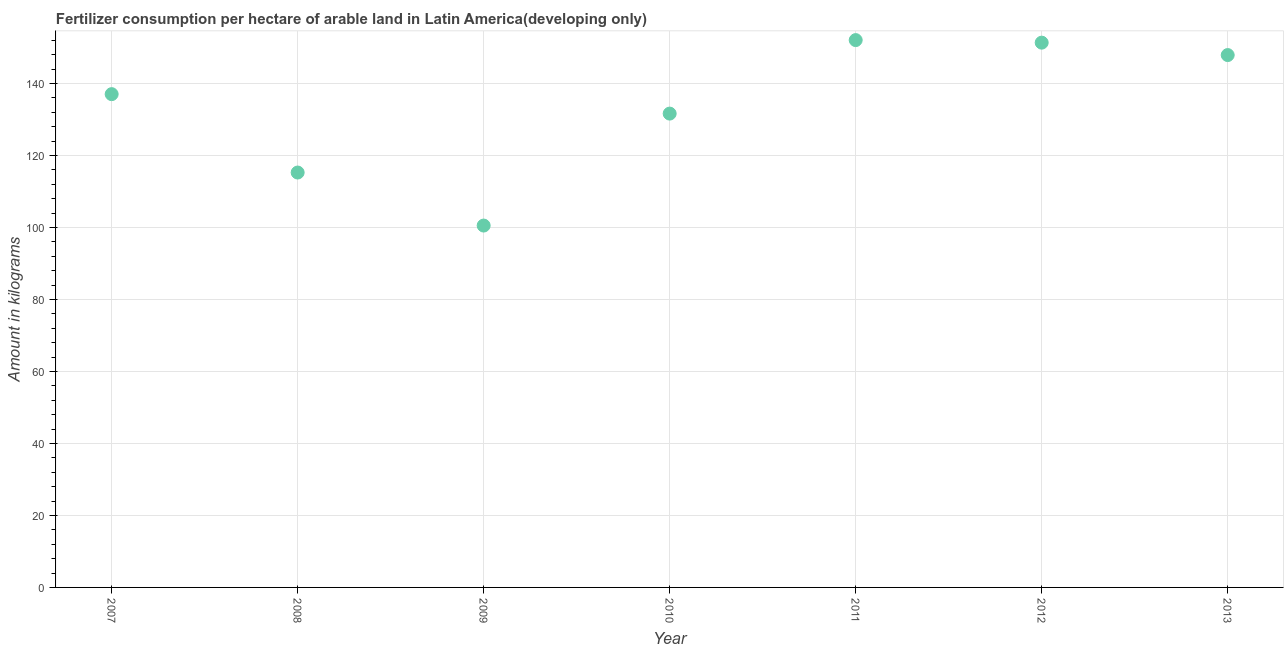What is the amount of fertilizer consumption in 2012?
Make the answer very short. 151.32. Across all years, what is the maximum amount of fertilizer consumption?
Your response must be concise. 152.03. Across all years, what is the minimum amount of fertilizer consumption?
Your answer should be compact. 100.52. In which year was the amount of fertilizer consumption maximum?
Your answer should be compact. 2011. What is the sum of the amount of fertilizer consumption?
Make the answer very short. 935.62. What is the difference between the amount of fertilizer consumption in 2008 and 2009?
Offer a terse response. 14.73. What is the average amount of fertilizer consumption per year?
Ensure brevity in your answer.  133.66. What is the median amount of fertilizer consumption?
Your answer should be very brief. 137.02. In how many years, is the amount of fertilizer consumption greater than 72 kg?
Keep it short and to the point. 7. Do a majority of the years between 2012 and 2010 (inclusive) have amount of fertilizer consumption greater than 100 kg?
Your answer should be compact. No. What is the ratio of the amount of fertilizer consumption in 2009 to that in 2011?
Offer a very short reply. 0.66. What is the difference between the highest and the second highest amount of fertilizer consumption?
Your answer should be very brief. 0.71. Is the sum of the amount of fertilizer consumption in 2009 and 2013 greater than the maximum amount of fertilizer consumption across all years?
Offer a terse response. Yes. What is the difference between the highest and the lowest amount of fertilizer consumption?
Keep it short and to the point. 51.52. How many dotlines are there?
Ensure brevity in your answer.  1. How many years are there in the graph?
Give a very brief answer. 7. What is the difference between two consecutive major ticks on the Y-axis?
Provide a short and direct response. 20. Does the graph contain any zero values?
Your answer should be very brief. No. What is the title of the graph?
Make the answer very short. Fertilizer consumption per hectare of arable land in Latin America(developing only) . What is the label or title of the X-axis?
Your answer should be compact. Year. What is the label or title of the Y-axis?
Your response must be concise. Amount in kilograms. What is the Amount in kilograms in 2007?
Give a very brief answer. 137.02. What is the Amount in kilograms in 2008?
Your answer should be compact. 115.25. What is the Amount in kilograms in 2009?
Your answer should be very brief. 100.52. What is the Amount in kilograms in 2010?
Your answer should be very brief. 131.62. What is the Amount in kilograms in 2011?
Provide a succinct answer. 152.03. What is the Amount in kilograms in 2012?
Ensure brevity in your answer.  151.32. What is the Amount in kilograms in 2013?
Provide a succinct answer. 147.87. What is the difference between the Amount in kilograms in 2007 and 2008?
Offer a terse response. 21.77. What is the difference between the Amount in kilograms in 2007 and 2009?
Make the answer very short. 36.5. What is the difference between the Amount in kilograms in 2007 and 2010?
Give a very brief answer. 5.4. What is the difference between the Amount in kilograms in 2007 and 2011?
Your answer should be compact. -15.02. What is the difference between the Amount in kilograms in 2007 and 2012?
Your answer should be very brief. -14.31. What is the difference between the Amount in kilograms in 2007 and 2013?
Your response must be concise. -10.86. What is the difference between the Amount in kilograms in 2008 and 2009?
Provide a succinct answer. 14.73. What is the difference between the Amount in kilograms in 2008 and 2010?
Provide a succinct answer. -16.37. What is the difference between the Amount in kilograms in 2008 and 2011?
Keep it short and to the point. -36.79. What is the difference between the Amount in kilograms in 2008 and 2012?
Your answer should be very brief. -36.08. What is the difference between the Amount in kilograms in 2008 and 2013?
Offer a very short reply. -32.63. What is the difference between the Amount in kilograms in 2009 and 2010?
Your answer should be very brief. -31.1. What is the difference between the Amount in kilograms in 2009 and 2011?
Offer a very short reply. -51.52. What is the difference between the Amount in kilograms in 2009 and 2012?
Your answer should be compact. -50.81. What is the difference between the Amount in kilograms in 2009 and 2013?
Give a very brief answer. -47.36. What is the difference between the Amount in kilograms in 2010 and 2011?
Keep it short and to the point. -20.42. What is the difference between the Amount in kilograms in 2010 and 2012?
Offer a terse response. -19.71. What is the difference between the Amount in kilograms in 2010 and 2013?
Provide a short and direct response. -16.26. What is the difference between the Amount in kilograms in 2011 and 2012?
Your answer should be very brief. 0.71. What is the difference between the Amount in kilograms in 2011 and 2013?
Your response must be concise. 4.16. What is the difference between the Amount in kilograms in 2012 and 2013?
Ensure brevity in your answer.  3.45. What is the ratio of the Amount in kilograms in 2007 to that in 2008?
Give a very brief answer. 1.19. What is the ratio of the Amount in kilograms in 2007 to that in 2009?
Make the answer very short. 1.36. What is the ratio of the Amount in kilograms in 2007 to that in 2010?
Give a very brief answer. 1.04. What is the ratio of the Amount in kilograms in 2007 to that in 2011?
Provide a succinct answer. 0.9. What is the ratio of the Amount in kilograms in 2007 to that in 2012?
Keep it short and to the point. 0.91. What is the ratio of the Amount in kilograms in 2007 to that in 2013?
Offer a very short reply. 0.93. What is the ratio of the Amount in kilograms in 2008 to that in 2009?
Your answer should be very brief. 1.15. What is the ratio of the Amount in kilograms in 2008 to that in 2010?
Give a very brief answer. 0.88. What is the ratio of the Amount in kilograms in 2008 to that in 2011?
Offer a terse response. 0.76. What is the ratio of the Amount in kilograms in 2008 to that in 2012?
Give a very brief answer. 0.76. What is the ratio of the Amount in kilograms in 2008 to that in 2013?
Your answer should be very brief. 0.78. What is the ratio of the Amount in kilograms in 2009 to that in 2010?
Your answer should be very brief. 0.76. What is the ratio of the Amount in kilograms in 2009 to that in 2011?
Your response must be concise. 0.66. What is the ratio of the Amount in kilograms in 2009 to that in 2012?
Your answer should be compact. 0.66. What is the ratio of the Amount in kilograms in 2009 to that in 2013?
Offer a terse response. 0.68. What is the ratio of the Amount in kilograms in 2010 to that in 2011?
Provide a succinct answer. 0.87. What is the ratio of the Amount in kilograms in 2010 to that in 2012?
Your answer should be very brief. 0.87. What is the ratio of the Amount in kilograms in 2010 to that in 2013?
Provide a succinct answer. 0.89. What is the ratio of the Amount in kilograms in 2011 to that in 2013?
Your answer should be compact. 1.03. 